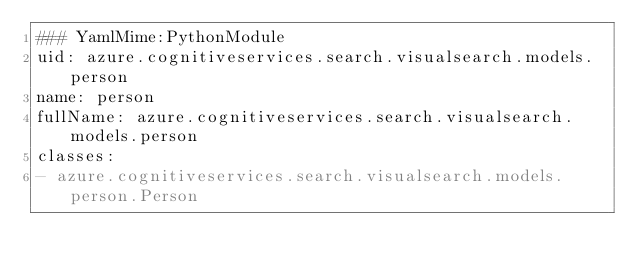Convert code to text. <code><loc_0><loc_0><loc_500><loc_500><_YAML_>### YamlMime:PythonModule
uid: azure.cognitiveservices.search.visualsearch.models.person
name: person
fullName: azure.cognitiveservices.search.visualsearch.models.person
classes:
- azure.cognitiveservices.search.visualsearch.models.person.Person
</code> 